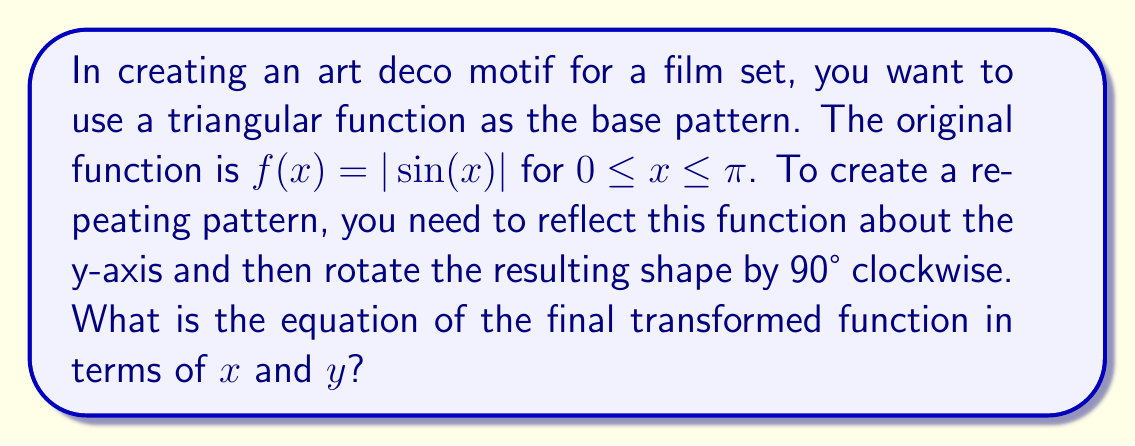Help me with this question. 1) First, let's reflect $f(x) = |\sin(x)|$ about the y-axis:
   The reflection of a function about the y-axis is given by $f(-x)$.
   So, the reflected function is $g(x) = |\sin(-x)| = |\sin(x)|$

2) Now we have the function defined for $-\pi \leq x \leq \pi$.

3) To rotate this by 90° clockwise, we need to:
   a) Swap $x$ and $y$
   b) Negate the new $y$

4) After swapping, we get: $x = |\sin(y)|$

5) Negating $y$: $x = |\sin(-y)| = |\sin(y)|$

6) Solving for $y$:
   $x = |\sin(y)|$
   $\sin(y) = \pm x$
   $y = \arcsin(\pm x)$

7) The final equation should account for both positive and negative cases:
   $y = \pm \arcsin(x)$ for $-1 \leq x \leq 1$

This equation represents the art deco motif after reflection and rotation.
Answer: $y = \pm \arcsin(x)$ for $-1 \leq x \leq 1$ 